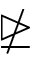<formula> <loc_0><loc_0><loc_500><loc_500>\ntrianglerighteq</formula> 